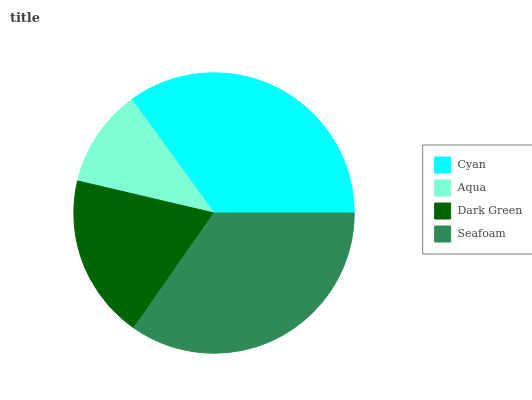Is Aqua the minimum?
Answer yes or no. Yes. Is Cyan the maximum?
Answer yes or no. Yes. Is Dark Green the minimum?
Answer yes or no. No. Is Dark Green the maximum?
Answer yes or no. No. Is Dark Green greater than Aqua?
Answer yes or no. Yes. Is Aqua less than Dark Green?
Answer yes or no. Yes. Is Aqua greater than Dark Green?
Answer yes or no. No. Is Dark Green less than Aqua?
Answer yes or no. No. Is Seafoam the high median?
Answer yes or no. Yes. Is Dark Green the low median?
Answer yes or no. Yes. Is Dark Green the high median?
Answer yes or no. No. Is Seafoam the low median?
Answer yes or no. No. 